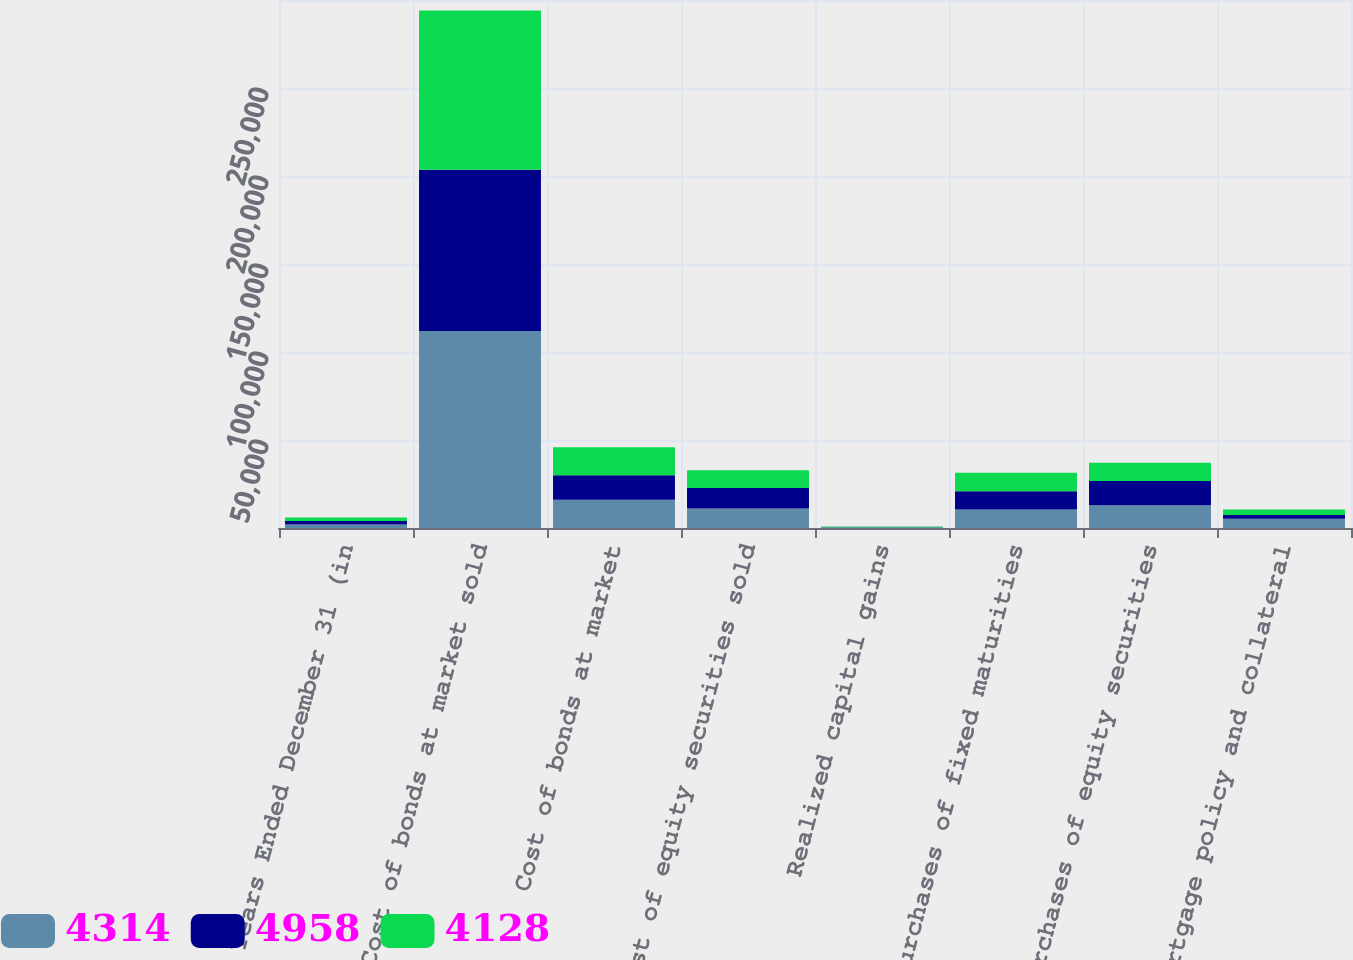Convert chart. <chart><loc_0><loc_0><loc_500><loc_500><stacked_bar_chart><ecel><fcel>Years Ended December 31 (in<fcel>Cost of bonds at market sold<fcel>Cost of bonds at market<fcel>Cost of equity securities sold<fcel>Realized capital gains<fcel>Purchases of fixed maturities<fcel>Purchases of equity securities<fcel>Mortgage policy and collateral<nl><fcel>4314<fcel>2005<fcel>111866<fcel>16017<fcel>11072<fcel>341<fcel>10473<fcel>12972<fcel>5306<nl><fcel>4958<fcel>2004<fcel>91714<fcel>13958<fcel>11711<fcel>44<fcel>10473<fcel>13674<fcel>2128<nl><fcel>4128<fcel>2003<fcel>90430<fcel>15966<fcel>10012<fcel>442<fcel>10473<fcel>10473<fcel>3016<nl></chart> 